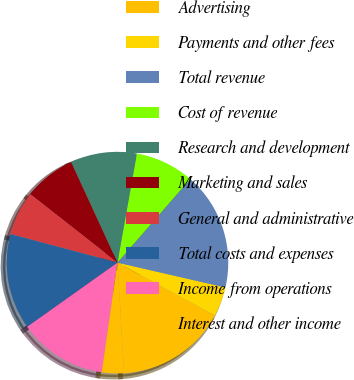<chart> <loc_0><loc_0><loc_500><loc_500><pie_chart><fcel>Advertising<fcel>Payments and other fees<fcel>Total revenue<fcel>Cost of revenue<fcel>Research and development<fcel>Marketing and sales<fcel>General and administrative<fcel>Total costs and expenses<fcel>Income from operations<fcel>Interest and other income<nl><fcel>16.13%<fcel>4.3%<fcel>17.2%<fcel>8.6%<fcel>9.68%<fcel>7.53%<fcel>6.45%<fcel>13.98%<fcel>12.9%<fcel>3.23%<nl></chart> 